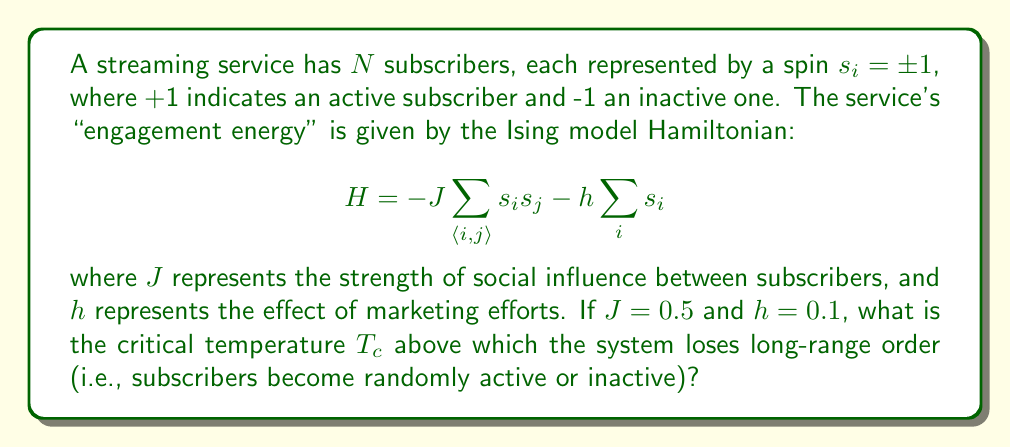Give your solution to this math problem. To find the critical temperature for this Ising model, we'll follow these steps:

1) For a 2D square lattice Ising model, the critical temperature is given by the Onsager solution:

   $$ \frac{k_BT_c}{J} = \frac{2}{\ln(1+\sqrt{2})} \approx 2.269 $$

   where $k_B$ is the Boltzmann constant.

2) However, this is for the case where $h=0$. In our case, $h \neq 0$, which complicates the solution. The presence of an external field ($h$) tends to destroy the phase transition, but for small $h$, we can approximate the critical temperature using a mean-field approach.

3) In the mean-field approximation, the critical temperature is given by:

   $$ k_BT_c = zJ $$

   where $z$ is the coordination number (number of nearest neighbors). For a 2D square lattice, $z=4$.

4) Substituting the given value of $J=0.5$:

   $$ k_BT_c = 4 \cdot 0.5 = 2 $$

5) To express this in terms of temperature, we divide by $k_B$:

   $$ T_c = \frac{2}{k_B} $$

6) Note that this is an approximation, and the actual critical temperature will be slightly lower due to the presence of the external field $h$.

7) The small value of $h$ (0.1) compared to $J$ (0.5) suggests that this approximation is reasonable, but not exact.
Answer: $T_c \approx \frac{2}{k_B}$ 